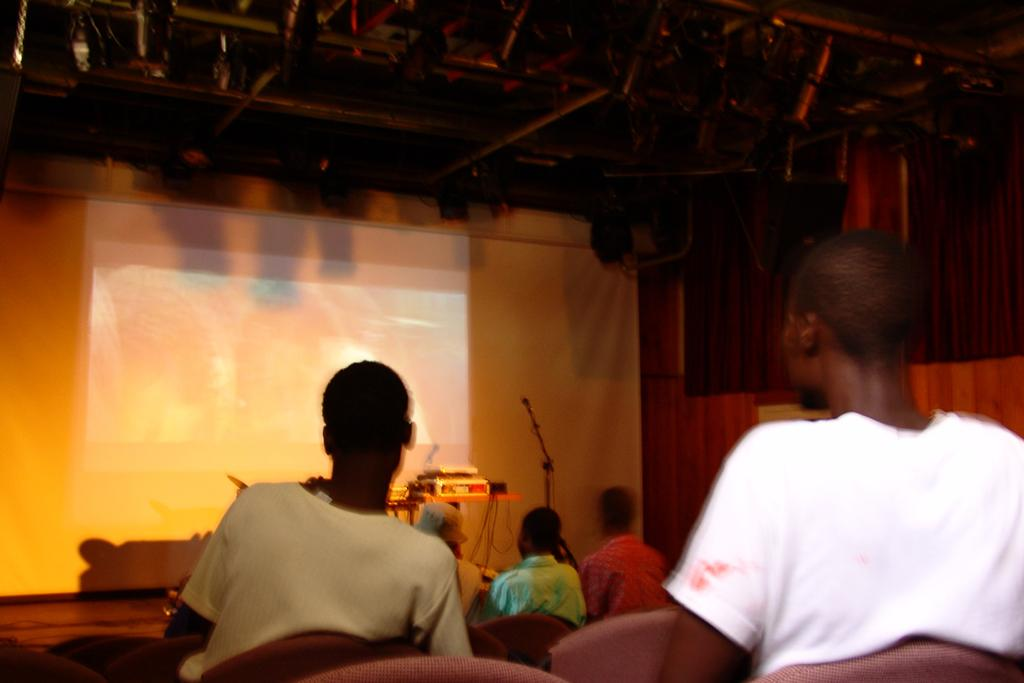What are the people in the image doing? The people in the image are sitting on chairs. What is in front of the chairs? There is a table in front of the chairs. What object is on the table? A projector is present on the table. What is visible in the background of the image? There is a screen in the background of the image. What type of plastic bottle can be seen on the screen in the image? There is no plastic bottle present on the screen in the image. 